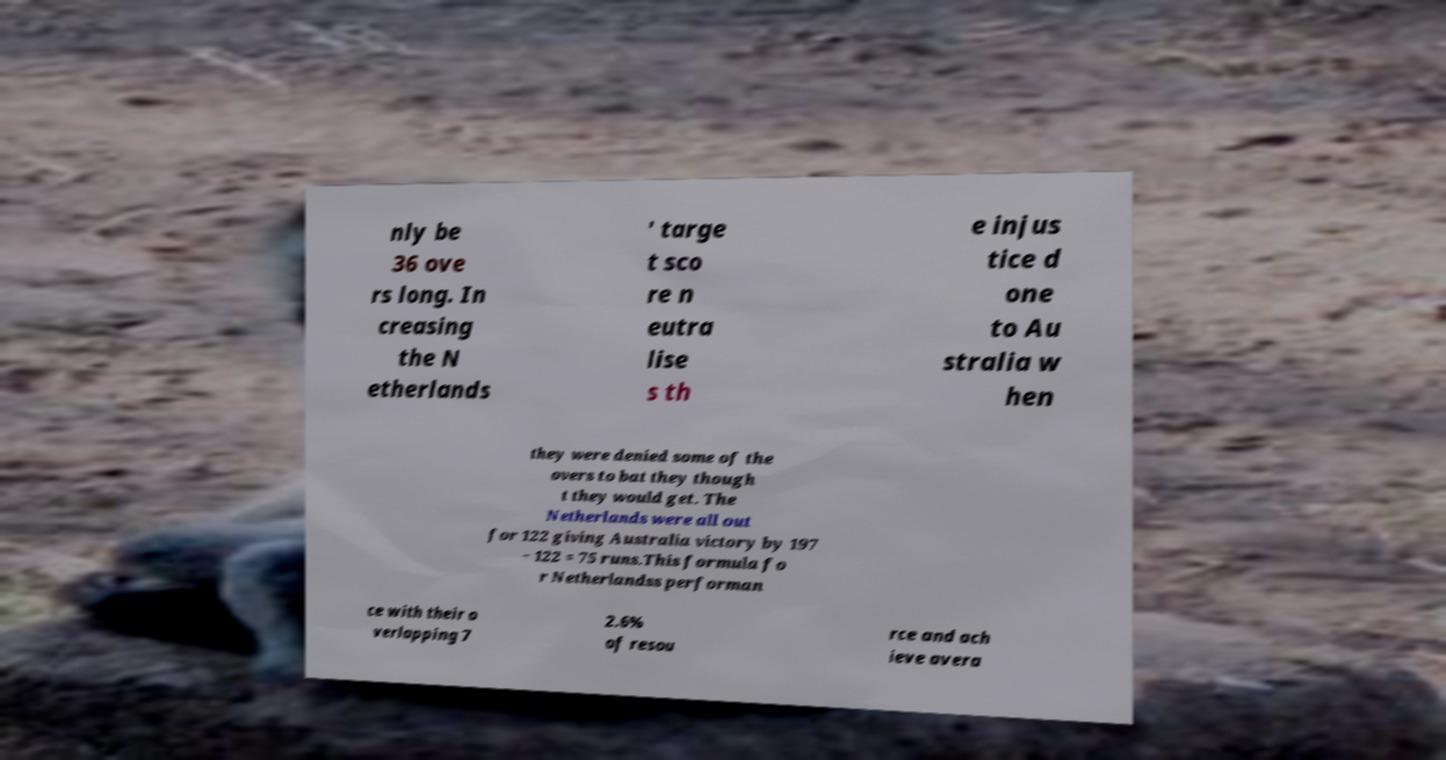Could you assist in decoding the text presented in this image and type it out clearly? nly be 36 ove rs long. In creasing the N etherlands ' targe t sco re n eutra lise s th e injus tice d one to Au stralia w hen they were denied some of the overs to bat they though t they would get. The Netherlands were all out for 122 giving Australia victory by 197 − 122 = 75 runs.This formula fo r Netherlandss performan ce with their o verlapping 7 2.6% of resou rce and ach ieve avera 